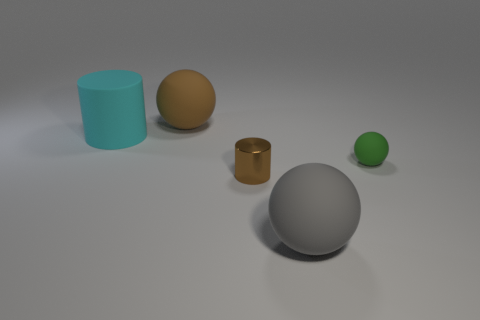Is the number of big purple matte cylinders greater than the number of green spheres?
Your answer should be very brief. No. What is the material of the brown cylinder?
Provide a succinct answer. Metal. There is a gray rubber thing that is the same shape as the big brown object; what size is it?
Your answer should be compact. Large. There is a matte sphere that is on the left side of the gray matte object; is there a large rubber thing on the right side of it?
Offer a very short reply. Yes. Is the color of the big rubber cylinder the same as the small shiny thing?
Make the answer very short. No. How many other objects are there of the same shape as the large cyan object?
Keep it short and to the point. 1. Is the number of cylinders that are in front of the tiny green thing greater than the number of tiny brown shiny objects behind the tiny brown thing?
Provide a succinct answer. Yes. There is a brown thing that is right of the brown matte sphere; is its size the same as the matte sphere to the right of the gray rubber thing?
Ensure brevity in your answer.  Yes. The cyan object has what shape?
Your answer should be very brief. Cylinder. There is another tiny object that is the same material as the cyan thing; what color is it?
Your response must be concise. Green. 